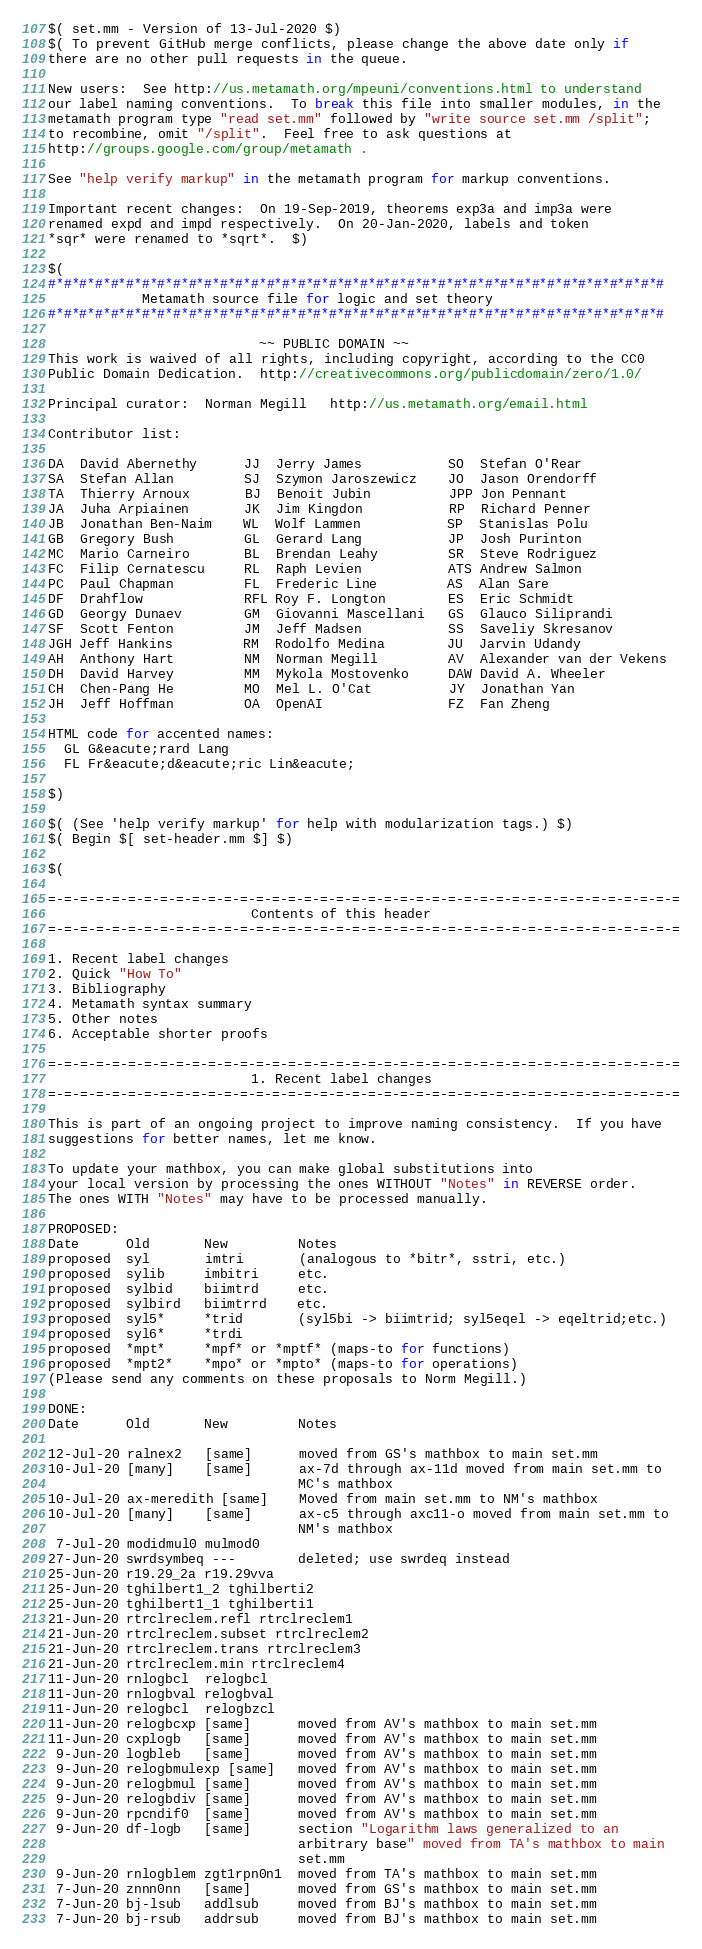<code> <loc_0><loc_0><loc_500><loc_500><_ObjectiveC_>$( set.mm - Version of 13-Jul-2020 $)
$( To prevent GitHub merge conflicts, please change the above date only if
there are no other pull requests in the queue.

New users:  See http://us.metamath.org/mpeuni/conventions.html to understand
our label naming conventions.  To break this file into smaller modules, in the
metamath program type "read set.mm" followed by "write source set.mm /split";
to recombine, omit "/split".  Feel free to ask questions at
http://groups.google.com/group/metamath .

See "help verify markup" in the metamath program for markup conventions.

Important recent changes:  On 19-Sep-2019, theorems exp3a and imp3a were
renamed expd and impd respectively.  On 20-Jan-2020, labels and token
*sqr* were renamed to *sqrt*.  $)

$(
#*#*#*#*#*#*#*#*#*#*#*#*#*#*#*#*#*#*#*#*#*#*#*#*#*#*#*#*#*#*#*#*#*#*#*#*#*#*#*#
            Metamath source file for logic and set theory
#*#*#*#*#*#*#*#*#*#*#*#*#*#*#*#*#*#*#*#*#*#*#*#*#*#*#*#*#*#*#*#*#*#*#*#*#*#*#*#

                           ~~ PUBLIC DOMAIN ~~
This work is waived of all rights, including copyright, according to the CC0
Public Domain Dedication.  http://creativecommons.org/publicdomain/zero/1.0/

Principal curator:  Norman Megill   http://us.metamath.org/email.html

Contributor list:

DA  David Abernethy      JJ  Jerry James           SO  Stefan O'Rear
SA  Stefan Allan         SJ  Szymon Jaroszewicz    JO  Jason Orendorff
TA  Thierry Arnoux       BJ  Benoit Jubin          JPP Jon Pennant
JA  Juha Arpiainen       JK  Jim Kingdon           RP  Richard Penner
JB  Jonathan Ben-Naim    WL  Wolf Lammen           SP  Stanislas Polu
GB  Gregory Bush         GL  Gerard Lang           JP  Josh Purinton
MC  Mario Carneiro       BL  Brendan Leahy         SR  Steve Rodriguez
FC  Filip Cernatescu     RL  Raph Levien           ATS Andrew Salmon
PC  Paul Chapman         FL  Frederic Line         AS  Alan Sare
DF  Drahflow             RFL Roy F. Longton        ES  Eric Schmidt
GD  Georgy Dunaev        GM  Giovanni Mascellani   GS  Glauco Siliprandi
SF  Scott Fenton         JM  Jeff Madsen           SS  Saveliy Skresanov
JGH Jeff Hankins         RM  Rodolfo Medina        JU  Jarvin Udandy
AH  Anthony Hart         NM  Norman Megill         AV  Alexander van der Vekens
DH  David Harvey         MM  Mykola Mostovenko     DAW David A. Wheeler
CH  Chen-Pang He         MO  Mel L. O'Cat          JY  Jonathan Yan
JH  Jeff Hoffman         OA  OpenAI                FZ  Fan Zheng

HTML code for accented names:
  GL G&eacute;rard Lang
  FL Fr&eacute;d&eacute;ric Lin&eacute;

$)

$( (See 'help verify markup' for help with modularization tags.) $)
$( Begin $[ set-header.mm $] $)

$(

=-=-=-=-=-=-=-=-=-=-=-=-=-=-=-=-=-=-=-=-=-=-=-=-=-=-=-=-=-=-=-=-=-=-=-=-=-=-=-=
                          Contents of this header
=-=-=-=-=-=-=-=-=-=-=-=-=-=-=-=-=-=-=-=-=-=-=-=-=-=-=-=-=-=-=-=-=-=-=-=-=-=-=-=

1. Recent label changes
2. Quick "How To"
3. Bibliography
4. Metamath syntax summary
5. Other notes
6. Acceptable shorter proofs

=-=-=-=-=-=-=-=-=-=-=-=-=-=-=-=-=-=-=-=-=-=-=-=-=-=-=-=-=-=-=-=-=-=-=-=-=-=-=-=
                          1. Recent label changes
=-=-=-=-=-=-=-=-=-=-=-=-=-=-=-=-=-=-=-=-=-=-=-=-=-=-=-=-=-=-=-=-=-=-=-=-=-=-=-=

This is part of an ongoing project to improve naming consistency.  If you have
suggestions for better names, let me know.

To update your mathbox, you can make global substitutions into
your local version by processing the ones WITHOUT "Notes" in REVERSE order.
The ones WITH "Notes" may have to be processed manually.

PROPOSED:
Date      Old       New         Notes
proposed  syl       imtri       (analogous to *bitr*, sstri, etc.)
proposed  sylib     imbitri     etc.
proposed  sylbid    biimtrd     etc.
proposed  sylbird   biimtrrd    etc.
proposed  syl5*     *trid       (syl5bi -> biimtrid; syl5eqel -> eqeltrid;etc.)
proposed  syl6*     *trdi
proposed  *mpt*     *mpf* or *mptf* (maps-to for functions)
proposed  *mpt2*    *mpo* or *mpto* (maps-to for operations)
(Please send any comments on these proposals to Norm Megill.)

DONE:
Date      Old       New         Notes

12-Jul-20 ralnex2   [same]      moved from GS's mathbox to main set.mm
10-Jul-20 [many]    [same]      ax-7d through ax-11d moved from main set.mm to
                                MC's mathbox
10-Jul-20 ax-meredith [same]    Moved from main set.mm to NM's mathbox
10-Jul-20 [many]    [same]      ax-c5 through axc11-o moved from main set.mm to
                                NM's mathbox
 7-Jul-20 modidmul0 mulmod0
27-Jun-20 swrdsymbeq ---        deleted; use swrdeq instead
25-Jun-20 r19.29_2a r19.29vva
25-Jun-20 tghilbert1_2 tghilberti2
25-Jun-20 tghilbert1_1 tghilberti1
21-Jun-20 rtrclreclem.refl rtrclreclem1
21-Jun-20 rtrclreclem.subset rtrclreclem2
21-Jun-20 rtrclreclem.trans rtrclreclem3
21-Jun-20 rtrclreclem.min rtrclreclem4
11-Jun-20 rnlogbcl  relogbcl
11-Jun-20 rnlogbval relogbval
11-Jun-20 relogbcl  relogbzcl
11-Jun-20 relogbcxp [same]      moved from AV's mathbox to main set.mm
11-Jun-20 cxplogb   [same]      moved from AV's mathbox to main set.mm
 9-Jun-20 logbleb   [same]      moved from AV's mathbox to main set.mm
 9-Jun-20 relogbmulexp [same]   moved from AV's mathbox to main set.mm
 9-Jun-20 relogbmul [same]      moved from AV's mathbox to main set.mm
 9-Jun-20 relogbdiv [same]      moved from AV's mathbox to main set.mm
 9-Jun-20 rpcndif0  [same]      moved from AV's mathbox to main set.mm
 9-Jun-20 df-logb   [same]      section "Logarithm laws generalized to an
                                arbitrary base" moved from TA's mathbox to main
                                set.mm
 9-Jun-20 rnlogblem zgt1rpn0n1  moved from TA's mathbox to main set.mm
 7-Jun-20 znnn0nn   [same]      moved from GS's mathbox to main set.mm
 7-Jun-20 bj-lsub   addlsub     moved from BJ's mathbox to main set.mm
 7-Jun-20 bj-rsub   addrsub     moved from BJ's mathbox to main set.mm</code> 